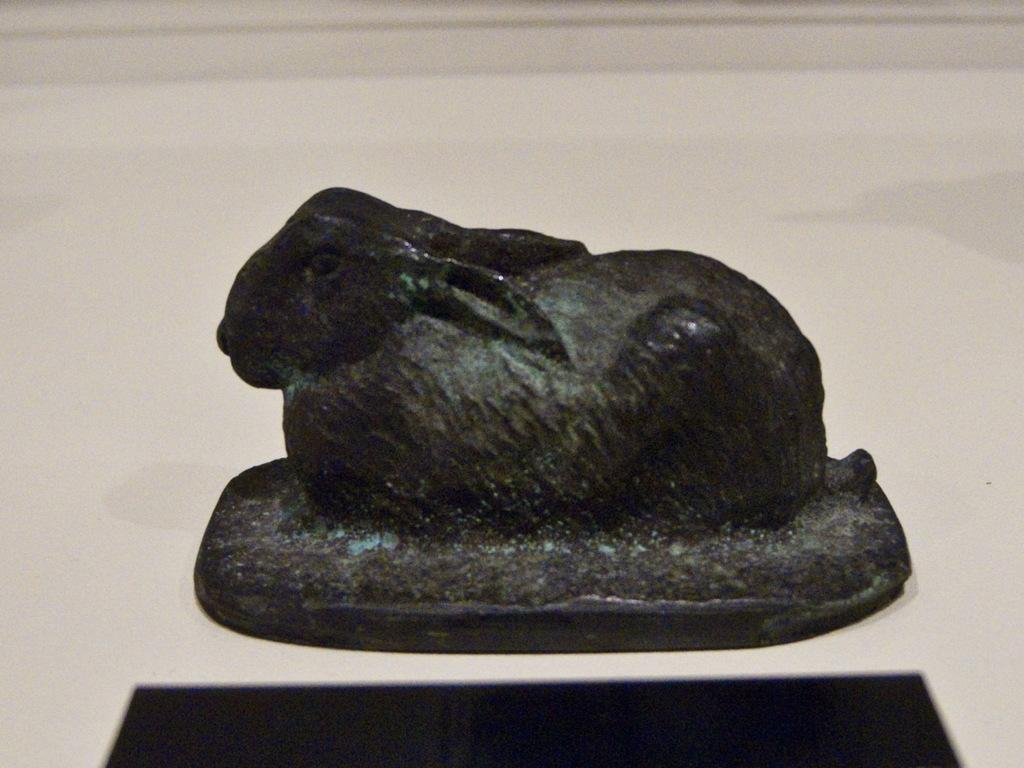What type of material is the sculpture made of in the image? The sculpture in the image is made of bronze. What type of silk fabric is draped over the roof in the image? There is no silk fabric or roof present in the image; it features a bronze sculpture. 